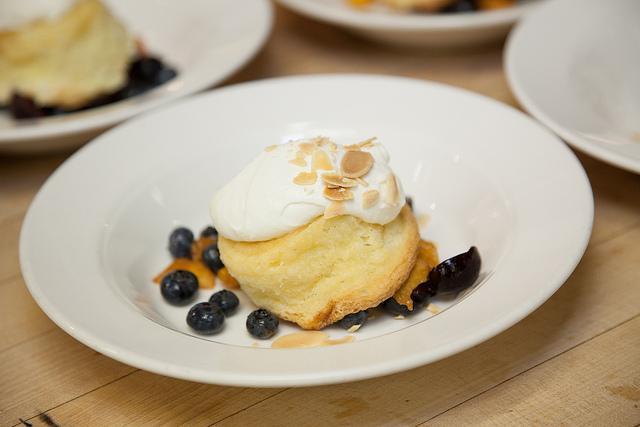How many slices are cut from the cake on the left?
Give a very brief answer. 0. How many bowls can you see?
Give a very brief answer. 4. How many cakes are visible?
Give a very brief answer. 3. How many people are wearing a tie?
Give a very brief answer. 0. 